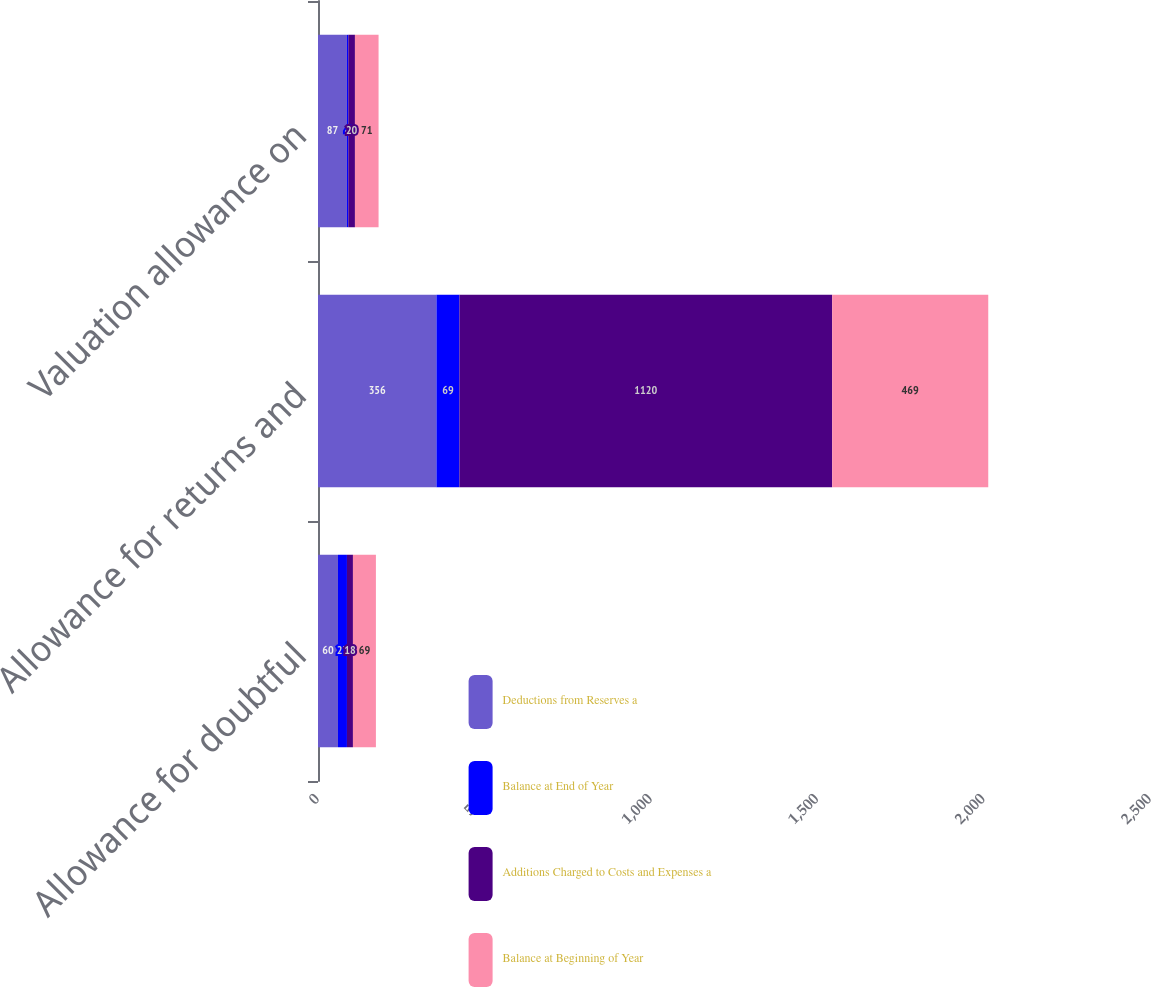Convert chart to OTSL. <chart><loc_0><loc_0><loc_500><loc_500><stacked_bar_chart><ecel><fcel>Allowance for doubtful<fcel>Allowance for returns and<fcel>Valuation allowance on<nl><fcel>Deductions from Reserves a<fcel>60<fcel>356<fcel>87<nl><fcel>Balance at End of Year<fcel>27<fcel>69<fcel>4<nl><fcel>Additions Charged to Costs and Expenses a<fcel>18<fcel>1120<fcel>20<nl><fcel>Balance at Beginning of Year<fcel>69<fcel>469<fcel>71<nl></chart> 